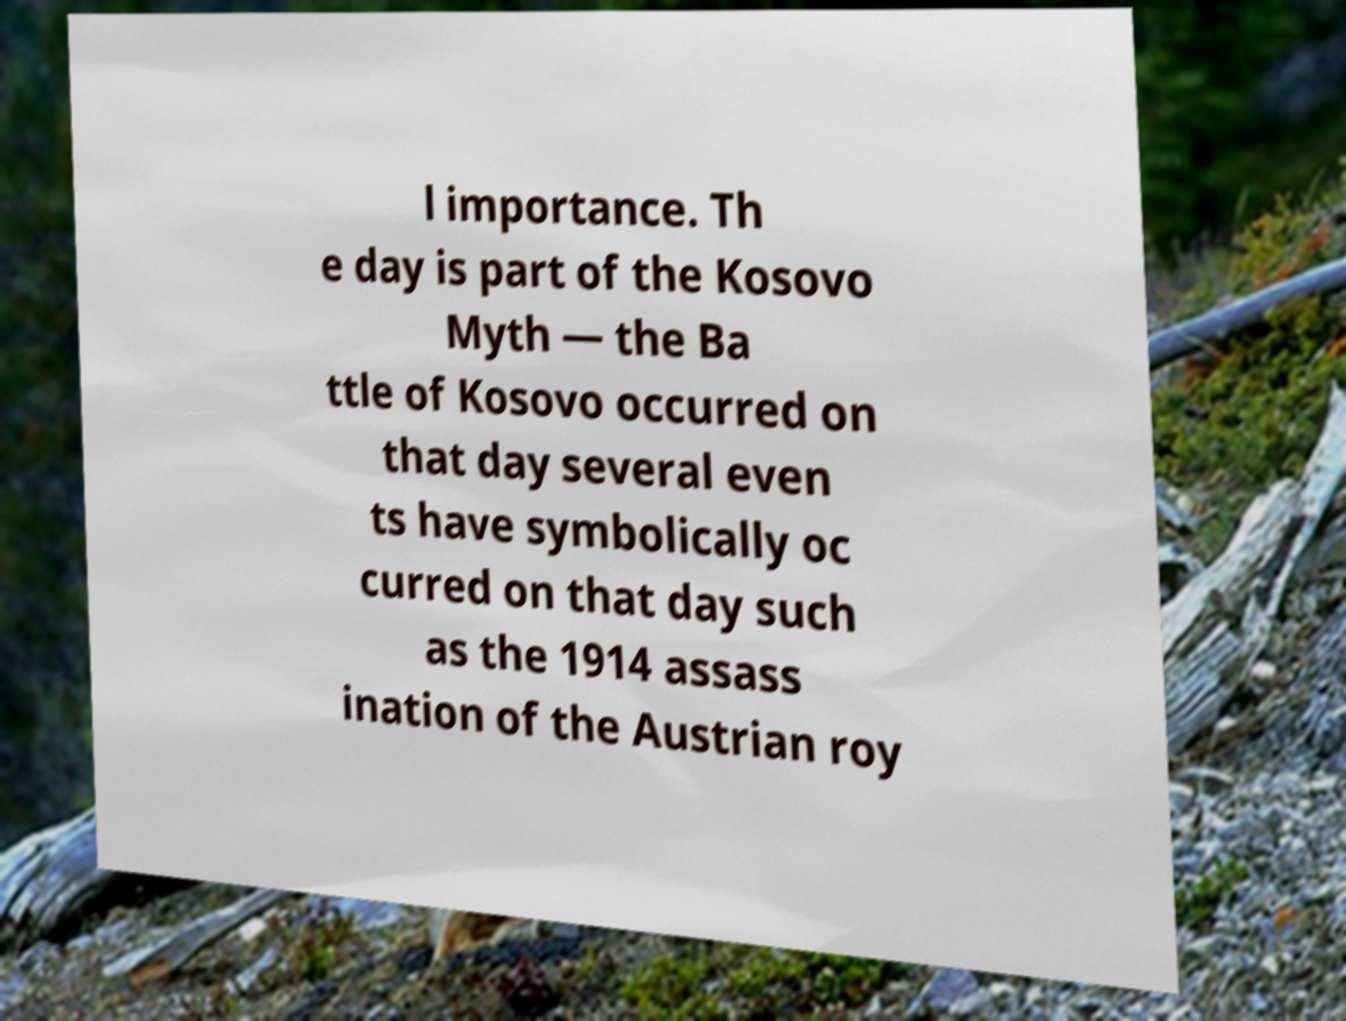Please identify and transcribe the text found in this image. l importance. Th e day is part of the Kosovo Myth — the Ba ttle of Kosovo occurred on that day several even ts have symbolically oc curred on that day such as the 1914 assass ination of the Austrian roy 